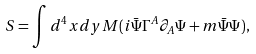Convert formula to latex. <formula><loc_0><loc_0><loc_500><loc_500>S = \int d ^ { 4 } x d y M ( i \bar { \Psi } \Gamma ^ { A } \partial _ { A } \Psi + m \bar { \Psi } \Psi ) ,</formula> 